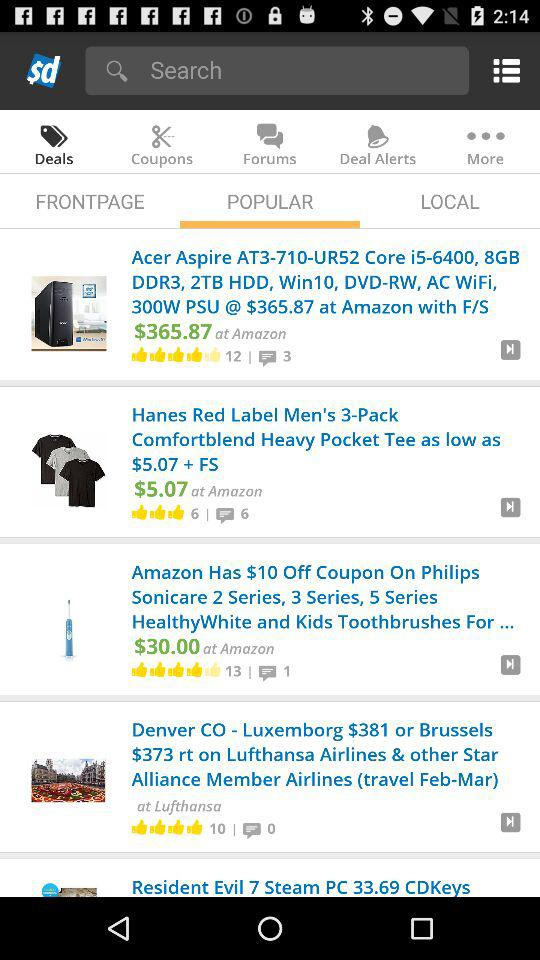How many thumbs up does the item with the highest rating have?
Answer the question using a single word or phrase. 13 